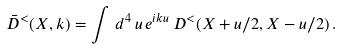<formula> <loc_0><loc_0><loc_500><loc_500>\bar { D } ^ { < } ( X , k ) = \int \, d ^ { 4 } \, u \, e ^ { i k u } \, D ^ { < } ( X + u / 2 , X - u / 2 ) \, .</formula> 